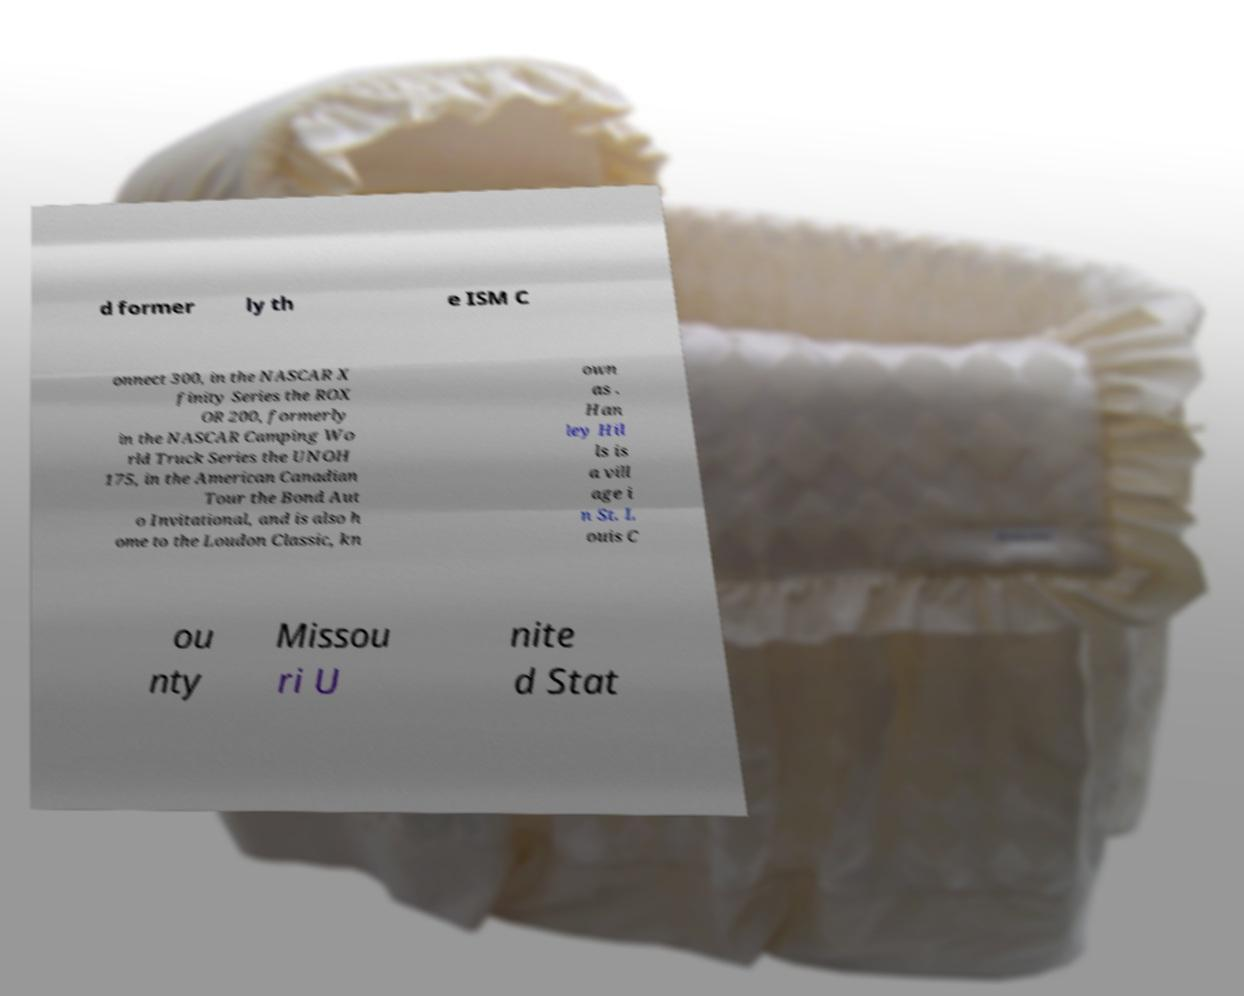Please read and relay the text visible in this image. What does it say? d former ly th e ISM C onnect 300, in the NASCAR X finity Series the ROX OR 200, formerly in the NASCAR Camping Wo rld Truck Series the UNOH 175, in the American Canadian Tour the Bond Aut o Invitational, and is also h ome to the Loudon Classic, kn own as . Han ley Hil ls is a vill age i n St. L ouis C ou nty Missou ri U nite d Stat 